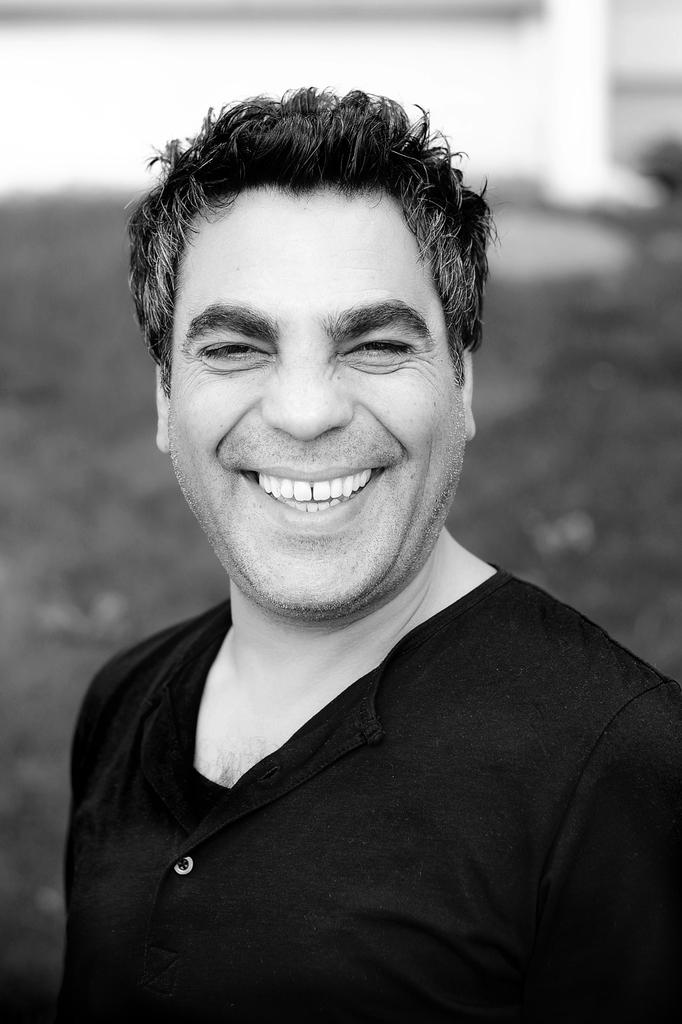What is the color scheme of the image? The image is black and white. Who is present in the image? There is a man in the image. What is the man's expression in the image? The man is smiling in the image. Can you describe the background of the image? The background of the image is blurred. What type of jelly can be seen in the image? There is no jelly present in the image. How many clovers are visible in the image? There are no clovers visible in the image. 